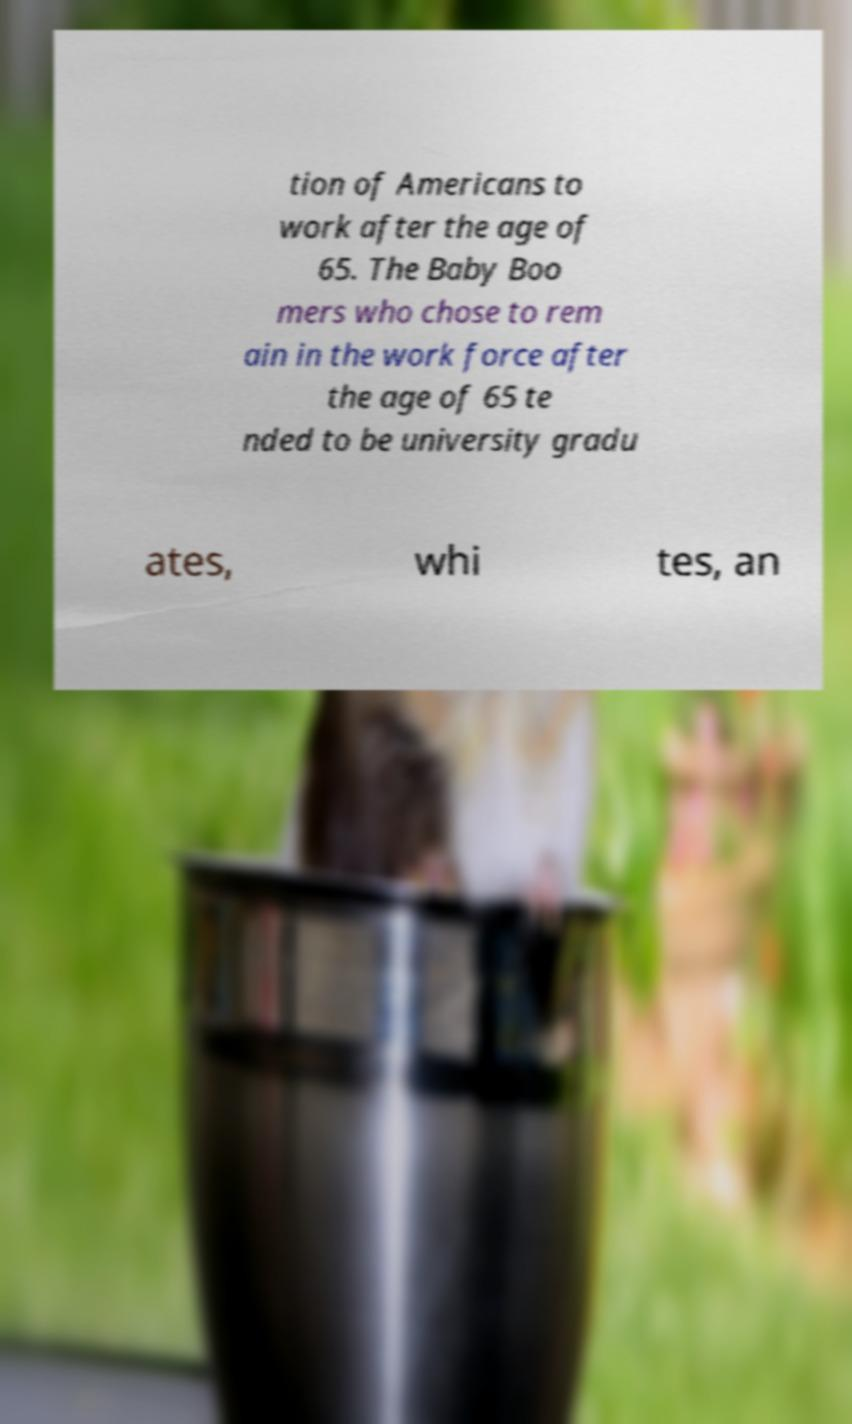Can you read and provide the text displayed in the image?This photo seems to have some interesting text. Can you extract and type it out for me? tion of Americans to work after the age of 65. The Baby Boo mers who chose to rem ain in the work force after the age of 65 te nded to be university gradu ates, whi tes, an 